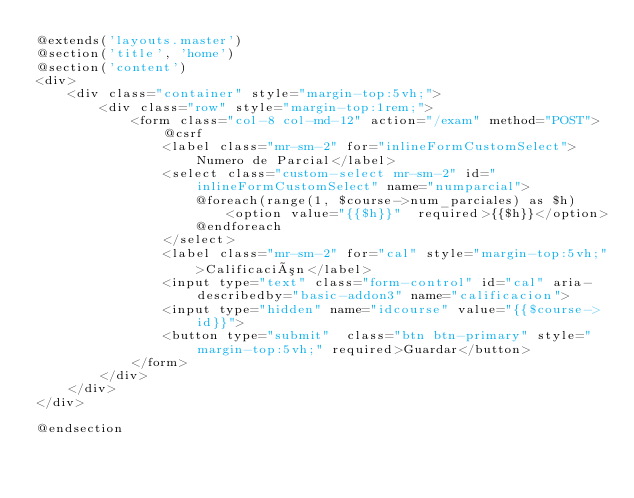Convert code to text. <code><loc_0><loc_0><loc_500><loc_500><_PHP_>@extends('layouts.master')
@section('title', 'home')
@section('content')
<div>
    <div class="container" style="margin-top:5vh;">
        <div class="row" style="margin-top:1rem;">
            <form class="col-8 col-md-12" action="/exam" method="POST">
                @csrf
                <label class="mr-sm-2" for="inlineFormCustomSelect">Numero de Parcial</label>
                <select class="custom-select mr-sm-2" id="inlineFormCustomSelect" name="numparcial">
                    @foreach(range(1, $course->num_parciales) as $h)
                        <option value="{{$h}}"  required>{{$h}}</option>
                    @endforeach
                </select>
                <label class="mr-sm-2" for="cal" style="margin-top:5vh;">Calificación</label>
                <input type="text" class="form-control" id="cal" aria-describedby="basic-addon3" name="calificacion">
                <input type="hidden" name="idcourse" value="{{$course->id}}">
                <button type="submit"  class="btn btn-primary" style="margin-top:5vh;" required>Guardar</button>
            </form>
        </div>
    </div>
</div>

@endsection
</code> 